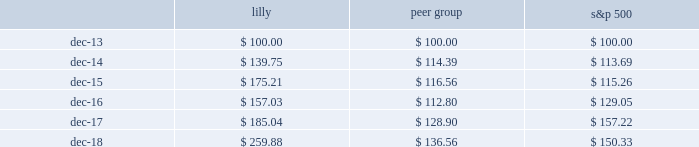Performance graph this graph compares the return on lilly stock with that of the standard & poor 2019s 500 stock index and our peer group for the years 2014 through 2018 .
The graph assumes that , on december 31 , 2013 , a person invested $ 100 each in lilly stock , the s&p 500 stock index , and the peer groups' common stock .
The graph measures total shareholder return , which takes into account both stock price and dividends .
It assumes that dividends paid by a company are reinvested in that company 2019s stock .
Value of $ 100 invested on last business day of 2013 comparison of five-year cumulative total return among lilly , s&p 500 stock index , peer group ( 1 ) .
( 1 ) we constructed the peer group as the industry index for this graph .
It comprises the companies in the pharmaceutical and biotech industries that we used to benchmark the compensation of our executive officers for 2018 : abbvie inc. ; amgen inc. ; astrazeneca plc ; baxter international inc. ; biogen idec inc. ; bristol-myers squibb company ; celgene corporation ; gilead sciences inc. ; glaxosmithkline plc ; johnson & johnson ; medtronic plc ; merck & co. , inc. ; novartis ag. ; pfizer inc. ; roche holdings ag ; sanofi ; and shire plc. .
What was the difference in percentage return for lilly compared to the peer group for the five years ended dec-18? 
Computations: (((259.88 - 100) / 100) - ((136.56 - 100) / 100))
Answer: 1.2332. Performance graph this graph compares the return on lilly stock with that of the standard & poor 2019s 500 stock index and our peer group for the years 2014 through 2018 .
The graph assumes that , on december 31 , 2013 , a person invested $ 100 each in lilly stock , the s&p 500 stock index , and the peer groups' common stock .
The graph measures total shareholder return , which takes into account both stock price and dividends .
It assumes that dividends paid by a company are reinvested in that company 2019s stock .
Value of $ 100 invested on last business day of 2013 comparison of five-year cumulative total return among lilly , s&p 500 stock index , peer group ( 1 ) .
( 1 ) we constructed the peer group as the industry index for this graph .
It comprises the companies in the pharmaceutical and biotech industries that we used to benchmark the compensation of our executive officers for 2018 : abbvie inc. ; amgen inc. ; astrazeneca plc ; baxter international inc. ; biogen idec inc. ; bristol-myers squibb company ; celgene corporation ; gilead sciences inc. ; glaxosmithkline plc ; johnson & johnson ; medtronic plc ; merck & co. , inc. ; novartis ag. ; pfizer inc. ; roche holdings ag ; sanofi ; and shire plc. .
What was the difference in percentage return for lilly compared to the s&p 500 for the five years ended dec-18? 
Computations: (((259.88 - 100) / 100) - ((150.33 - 100) / 100))
Answer: 1.0955. Performance graph this graph compares the return on lilly stock with that of the standard & poor 2019s 500 stock index and our peer group for the years 2014 through 2018 .
The graph assumes that , on december 31 , 2013 , a person invested $ 100 each in lilly stock , the s&p 500 stock index , and the peer groups' common stock .
The graph measures total shareholder return , which takes into account both stock price and dividends .
It assumes that dividends paid by a company are reinvested in that company 2019s stock .
Value of $ 100 invested on last business day of 2013 comparison of five-year cumulative total return among lilly , s&p 500 stock index , peer group ( 1 ) .
( 1 ) we constructed the peer group as the industry index for this graph .
It comprises the companies in the pharmaceutical and biotech industries that we used to benchmark the compensation of our executive officers for 2018 : abbvie inc. ; amgen inc. ; astrazeneca plc ; baxter international inc. ; biogen idec inc. ; bristol-myers squibb company ; celgene corporation ; gilead sciences inc. ; glaxosmithkline plc ; johnson & johnson ; medtronic plc ; merck & co. , inc. ; novartis ag. ; pfizer inc. ; roche holdings ag ; sanofi ; and shire plc. .
As of december 312017 what was the ratio of the value of the lilly to the peer group? 
Rationale: as of december 312017 the cumulative return of lilly was 1.44 times that of the peer group
Computations: (185.04 / 128.90)
Answer: 1.43553. 